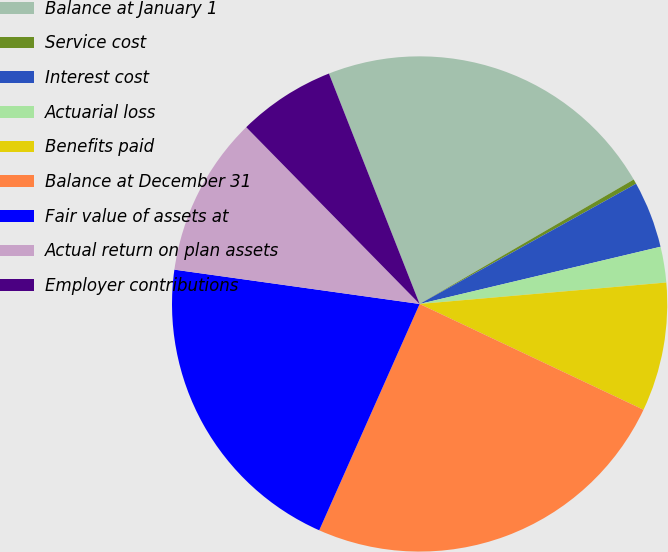Convert chart. <chart><loc_0><loc_0><loc_500><loc_500><pie_chart><fcel>Balance at January 1<fcel>Service cost<fcel>Interest cost<fcel>Actuarial loss<fcel>Benefits paid<fcel>Balance at December 31<fcel>Fair value of assets at<fcel>Actual return on plan assets<fcel>Employer contributions<nl><fcel>22.59%<fcel>0.31%<fcel>4.36%<fcel>2.33%<fcel>8.41%<fcel>24.62%<fcel>20.57%<fcel>10.44%<fcel>6.38%<nl></chart> 